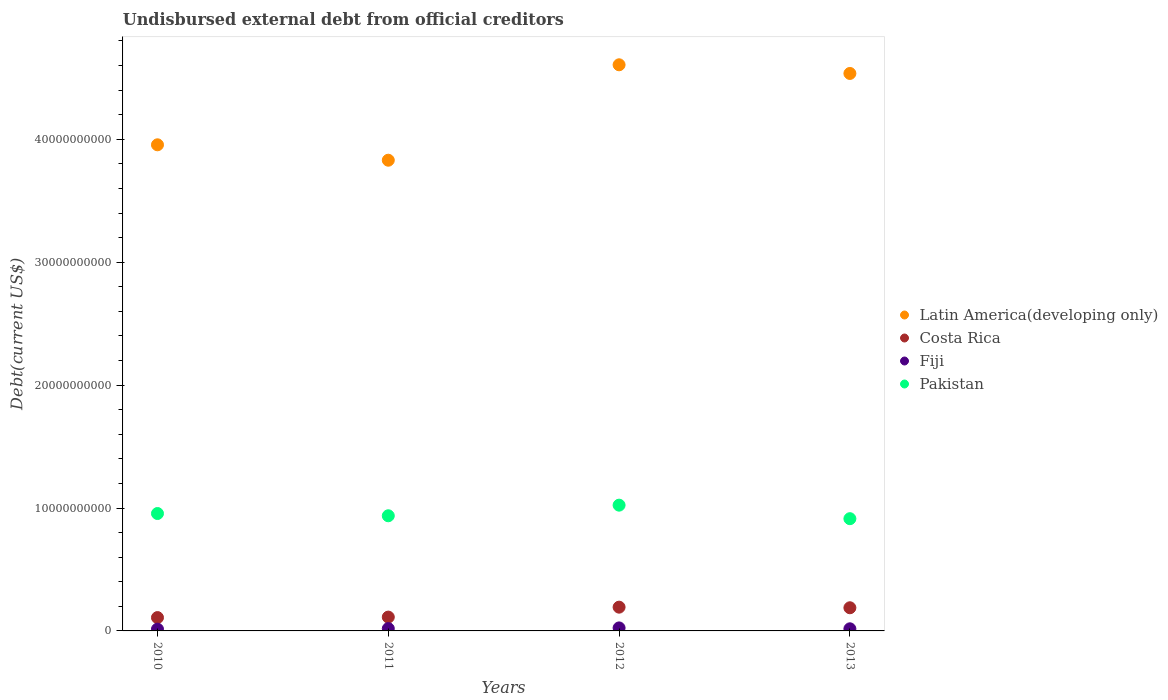How many different coloured dotlines are there?
Your response must be concise. 4. What is the total debt in Fiji in 2013?
Offer a very short reply. 1.72e+08. Across all years, what is the maximum total debt in Fiji?
Your answer should be very brief. 2.45e+08. Across all years, what is the minimum total debt in Pakistan?
Your answer should be very brief. 9.13e+09. In which year was the total debt in Pakistan maximum?
Make the answer very short. 2012. What is the total total debt in Fiji in the graph?
Give a very brief answer. 7.51e+08. What is the difference between the total debt in Latin America(developing only) in 2012 and that in 2013?
Keep it short and to the point. 7.05e+08. What is the difference between the total debt in Latin America(developing only) in 2013 and the total debt in Pakistan in 2012?
Your answer should be very brief. 3.51e+1. What is the average total debt in Costa Rica per year?
Provide a short and direct response. 1.51e+09. In the year 2011, what is the difference between the total debt in Pakistan and total debt in Fiji?
Provide a succinct answer. 9.18e+09. In how many years, is the total debt in Costa Rica greater than 32000000000 US$?
Your answer should be compact. 0. What is the ratio of the total debt in Pakistan in 2011 to that in 2013?
Make the answer very short. 1.03. Is the total debt in Pakistan in 2010 less than that in 2011?
Make the answer very short. No. Is the difference between the total debt in Pakistan in 2011 and 2013 greater than the difference between the total debt in Fiji in 2011 and 2013?
Your answer should be very brief. Yes. What is the difference between the highest and the second highest total debt in Latin America(developing only)?
Your answer should be compact. 7.05e+08. What is the difference between the highest and the lowest total debt in Latin America(developing only)?
Offer a very short reply. 7.76e+09. Is the sum of the total debt in Fiji in 2012 and 2013 greater than the maximum total debt in Costa Rica across all years?
Your answer should be compact. No. Is it the case that in every year, the sum of the total debt in Costa Rica and total debt in Latin America(developing only)  is greater than the total debt in Fiji?
Provide a short and direct response. Yes. Is the total debt in Fiji strictly greater than the total debt in Pakistan over the years?
Your answer should be compact. No. Is the total debt in Latin America(developing only) strictly less than the total debt in Fiji over the years?
Your answer should be compact. No. How many dotlines are there?
Offer a very short reply. 4. How many years are there in the graph?
Keep it short and to the point. 4. Are the values on the major ticks of Y-axis written in scientific E-notation?
Keep it short and to the point. No. How many legend labels are there?
Provide a short and direct response. 4. How are the legend labels stacked?
Keep it short and to the point. Vertical. What is the title of the graph?
Provide a succinct answer. Undisbursed external debt from official creditors. What is the label or title of the Y-axis?
Offer a terse response. Debt(current US$). What is the Debt(current US$) of Latin America(developing only) in 2010?
Your answer should be compact. 3.95e+1. What is the Debt(current US$) of Costa Rica in 2010?
Provide a short and direct response. 1.09e+09. What is the Debt(current US$) of Fiji in 2010?
Offer a very short reply. 1.44e+08. What is the Debt(current US$) in Pakistan in 2010?
Give a very brief answer. 9.55e+09. What is the Debt(current US$) of Latin America(developing only) in 2011?
Provide a succinct answer. 3.83e+1. What is the Debt(current US$) in Costa Rica in 2011?
Keep it short and to the point. 1.12e+09. What is the Debt(current US$) of Fiji in 2011?
Keep it short and to the point. 1.90e+08. What is the Debt(current US$) of Pakistan in 2011?
Provide a short and direct response. 9.37e+09. What is the Debt(current US$) of Latin America(developing only) in 2012?
Your answer should be very brief. 4.61e+1. What is the Debt(current US$) in Costa Rica in 2012?
Offer a terse response. 1.93e+09. What is the Debt(current US$) in Fiji in 2012?
Keep it short and to the point. 2.45e+08. What is the Debt(current US$) of Pakistan in 2012?
Ensure brevity in your answer.  1.02e+1. What is the Debt(current US$) in Latin America(developing only) in 2013?
Give a very brief answer. 4.54e+1. What is the Debt(current US$) of Costa Rica in 2013?
Make the answer very short. 1.88e+09. What is the Debt(current US$) in Fiji in 2013?
Your answer should be compact. 1.72e+08. What is the Debt(current US$) of Pakistan in 2013?
Your response must be concise. 9.13e+09. Across all years, what is the maximum Debt(current US$) of Latin America(developing only)?
Your response must be concise. 4.61e+1. Across all years, what is the maximum Debt(current US$) of Costa Rica?
Offer a very short reply. 1.93e+09. Across all years, what is the maximum Debt(current US$) of Fiji?
Keep it short and to the point. 2.45e+08. Across all years, what is the maximum Debt(current US$) of Pakistan?
Provide a succinct answer. 1.02e+1. Across all years, what is the minimum Debt(current US$) of Latin America(developing only)?
Make the answer very short. 3.83e+1. Across all years, what is the minimum Debt(current US$) in Costa Rica?
Your answer should be compact. 1.09e+09. Across all years, what is the minimum Debt(current US$) of Fiji?
Ensure brevity in your answer.  1.44e+08. Across all years, what is the minimum Debt(current US$) in Pakistan?
Give a very brief answer. 9.13e+09. What is the total Debt(current US$) of Latin America(developing only) in the graph?
Your response must be concise. 1.69e+11. What is the total Debt(current US$) of Costa Rica in the graph?
Keep it short and to the point. 6.03e+09. What is the total Debt(current US$) in Fiji in the graph?
Offer a very short reply. 7.51e+08. What is the total Debt(current US$) in Pakistan in the graph?
Provide a succinct answer. 3.83e+1. What is the difference between the Debt(current US$) in Latin America(developing only) in 2010 and that in 2011?
Offer a very short reply. 1.25e+09. What is the difference between the Debt(current US$) of Costa Rica in 2010 and that in 2011?
Offer a terse response. -3.95e+07. What is the difference between the Debt(current US$) of Fiji in 2010 and that in 2011?
Provide a succinct answer. -4.60e+07. What is the difference between the Debt(current US$) of Pakistan in 2010 and that in 2011?
Provide a succinct answer. 1.83e+08. What is the difference between the Debt(current US$) in Latin America(developing only) in 2010 and that in 2012?
Give a very brief answer. -6.51e+09. What is the difference between the Debt(current US$) in Costa Rica in 2010 and that in 2012?
Your response must be concise. -8.48e+08. What is the difference between the Debt(current US$) in Fiji in 2010 and that in 2012?
Make the answer very short. -1.01e+08. What is the difference between the Debt(current US$) of Pakistan in 2010 and that in 2012?
Your response must be concise. -6.80e+08. What is the difference between the Debt(current US$) in Latin America(developing only) in 2010 and that in 2013?
Give a very brief answer. -5.80e+09. What is the difference between the Debt(current US$) in Costa Rica in 2010 and that in 2013?
Keep it short and to the point. -7.99e+08. What is the difference between the Debt(current US$) in Fiji in 2010 and that in 2013?
Offer a very short reply. -2.87e+07. What is the difference between the Debt(current US$) of Pakistan in 2010 and that in 2013?
Offer a very short reply. 4.20e+08. What is the difference between the Debt(current US$) in Latin America(developing only) in 2011 and that in 2012?
Make the answer very short. -7.76e+09. What is the difference between the Debt(current US$) of Costa Rica in 2011 and that in 2012?
Your answer should be very brief. -8.08e+08. What is the difference between the Debt(current US$) of Fiji in 2011 and that in 2012?
Give a very brief answer. -5.53e+07. What is the difference between the Debt(current US$) in Pakistan in 2011 and that in 2012?
Ensure brevity in your answer.  -8.64e+08. What is the difference between the Debt(current US$) in Latin America(developing only) in 2011 and that in 2013?
Your response must be concise. -7.06e+09. What is the difference between the Debt(current US$) of Costa Rica in 2011 and that in 2013?
Keep it short and to the point. -7.59e+08. What is the difference between the Debt(current US$) of Fiji in 2011 and that in 2013?
Your response must be concise. 1.74e+07. What is the difference between the Debt(current US$) of Pakistan in 2011 and that in 2013?
Provide a succinct answer. 2.37e+08. What is the difference between the Debt(current US$) of Latin America(developing only) in 2012 and that in 2013?
Offer a very short reply. 7.05e+08. What is the difference between the Debt(current US$) in Costa Rica in 2012 and that in 2013?
Make the answer very short. 4.90e+07. What is the difference between the Debt(current US$) in Fiji in 2012 and that in 2013?
Offer a terse response. 7.26e+07. What is the difference between the Debt(current US$) in Pakistan in 2012 and that in 2013?
Give a very brief answer. 1.10e+09. What is the difference between the Debt(current US$) in Latin America(developing only) in 2010 and the Debt(current US$) in Costa Rica in 2011?
Your answer should be very brief. 3.84e+1. What is the difference between the Debt(current US$) of Latin America(developing only) in 2010 and the Debt(current US$) of Fiji in 2011?
Your response must be concise. 3.94e+1. What is the difference between the Debt(current US$) in Latin America(developing only) in 2010 and the Debt(current US$) in Pakistan in 2011?
Your response must be concise. 3.02e+1. What is the difference between the Debt(current US$) of Costa Rica in 2010 and the Debt(current US$) of Fiji in 2011?
Offer a very short reply. 8.95e+08. What is the difference between the Debt(current US$) of Costa Rica in 2010 and the Debt(current US$) of Pakistan in 2011?
Offer a very short reply. -8.28e+09. What is the difference between the Debt(current US$) of Fiji in 2010 and the Debt(current US$) of Pakistan in 2011?
Ensure brevity in your answer.  -9.22e+09. What is the difference between the Debt(current US$) of Latin America(developing only) in 2010 and the Debt(current US$) of Costa Rica in 2012?
Make the answer very short. 3.76e+1. What is the difference between the Debt(current US$) in Latin America(developing only) in 2010 and the Debt(current US$) in Fiji in 2012?
Your answer should be very brief. 3.93e+1. What is the difference between the Debt(current US$) in Latin America(developing only) in 2010 and the Debt(current US$) in Pakistan in 2012?
Your response must be concise. 2.93e+1. What is the difference between the Debt(current US$) in Costa Rica in 2010 and the Debt(current US$) in Fiji in 2012?
Ensure brevity in your answer.  8.40e+08. What is the difference between the Debt(current US$) in Costa Rica in 2010 and the Debt(current US$) in Pakistan in 2012?
Ensure brevity in your answer.  -9.15e+09. What is the difference between the Debt(current US$) of Fiji in 2010 and the Debt(current US$) of Pakistan in 2012?
Provide a short and direct response. -1.01e+1. What is the difference between the Debt(current US$) in Latin America(developing only) in 2010 and the Debt(current US$) in Costa Rica in 2013?
Your response must be concise. 3.77e+1. What is the difference between the Debt(current US$) in Latin America(developing only) in 2010 and the Debt(current US$) in Fiji in 2013?
Your answer should be compact. 3.94e+1. What is the difference between the Debt(current US$) in Latin America(developing only) in 2010 and the Debt(current US$) in Pakistan in 2013?
Give a very brief answer. 3.04e+1. What is the difference between the Debt(current US$) in Costa Rica in 2010 and the Debt(current US$) in Fiji in 2013?
Provide a succinct answer. 9.13e+08. What is the difference between the Debt(current US$) of Costa Rica in 2010 and the Debt(current US$) of Pakistan in 2013?
Provide a short and direct response. -8.05e+09. What is the difference between the Debt(current US$) in Fiji in 2010 and the Debt(current US$) in Pakistan in 2013?
Give a very brief answer. -8.99e+09. What is the difference between the Debt(current US$) in Latin America(developing only) in 2011 and the Debt(current US$) in Costa Rica in 2012?
Give a very brief answer. 3.64e+1. What is the difference between the Debt(current US$) of Latin America(developing only) in 2011 and the Debt(current US$) of Fiji in 2012?
Your answer should be compact. 3.81e+1. What is the difference between the Debt(current US$) of Latin America(developing only) in 2011 and the Debt(current US$) of Pakistan in 2012?
Offer a terse response. 2.81e+1. What is the difference between the Debt(current US$) in Costa Rica in 2011 and the Debt(current US$) in Fiji in 2012?
Ensure brevity in your answer.  8.80e+08. What is the difference between the Debt(current US$) of Costa Rica in 2011 and the Debt(current US$) of Pakistan in 2012?
Offer a terse response. -9.11e+09. What is the difference between the Debt(current US$) in Fiji in 2011 and the Debt(current US$) in Pakistan in 2012?
Ensure brevity in your answer.  -1.00e+1. What is the difference between the Debt(current US$) of Latin America(developing only) in 2011 and the Debt(current US$) of Costa Rica in 2013?
Offer a very short reply. 3.64e+1. What is the difference between the Debt(current US$) in Latin America(developing only) in 2011 and the Debt(current US$) in Fiji in 2013?
Your response must be concise. 3.81e+1. What is the difference between the Debt(current US$) in Latin America(developing only) in 2011 and the Debt(current US$) in Pakistan in 2013?
Ensure brevity in your answer.  2.92e+1. What is the difference between the Debt(current US$) of Costa Rica in 2011 and the Debt(current US$) of Fiji in 2013?
Provide a succinct answer. 9.52e+08. What is the difference between the Debt(current US$) of Costa Rica in 2011 and the Debt(current US$) of Pakistan in 2013?
Offer a very short reply. -8.01e+09. What is the difference between the Debt(current US$) in Fiji in 2011 and the Debt(current US$) in Pakistan in 2013?
Provide a short and direct response. -8.94e+09. What is the difference between the Debt(current US$) in Latin America(developing only) in 2012 and the Debt(current US$) in Costa Rica in 2013?
Provide a short and direct response. 4.42e+1. What is the difference between the Debt(current US$) of Latin America(developing only) in 2012 and the Debt(current US$) of Fiji in 2013?
Offer a very short reply. 4.59e+1. What is the difference between the Debt(current US$) in Latin America(developing only) in 2012 and the Debt(current US$) in Pakistan in 2013?
Ensure brevity in your answer.  3.69e+1. What is the difference between the Debt(current US$) in Costa Rica in 2012 and the Debt(current US$) in Fiji in 2013?
Give a very brief answer. 1.76e+09. What is the difference between the Debt(current US$) of Costa Rica in 2012 and the Debt(current US$) of Pakistan in 2013?
Provide a short and direct response. -7.20e+09. What is the difference between the Debt(current US$) in Fiji in 2012 and the Debt(current US$) in Pakistan in 2013?
Make the answer very short. -8.89e+09. What is the average Debt(current US$) in Latin America(developing only) per year?
Provide a succinct answer. 4.23e+1. What is the average Debt(current US$) of Costa Rica per year?
Provide a succinct answer. 1.51e+09. What is the average Debt(current US$) in Fiji per year?
Provide a short and direct response. 1.88e+08. What is the average Debt(current US$) in Pakistan per year?
Offer a terse response. 9.57e+09. In the year 2010, what is the difference between the Debt(current US$) in Latin America(developing only) and Debt(current US$) in Costa Rica?
Keep it short and to the point. 3.85e+1. In the year 2010, what is the difference between the Debt(current US$) of Latin America(developing only) and Debt(current US$) of Fiji?
Provide a short and direct response. 3.94e+1. In the year 2010, what is the difference between the Debt(current US$) of Latin America(developing only) and Debt(current US$) of Pakistan?
Keep it short and to the point. 3.00e+1. In the year 2010, what is the difference between the Debt(current US$) of Costa Rica and Debt(current US$) of Fiji?
Your answer should be compact. 9.42e+08. In the year 2010, what is the difference between the Debt(current US$) of Costa Rica and Debt(current US$) of Pakistan?
Your answer should be compact. -8.47e+09. In the year 2010, what is the difference between the Debt(current US$) in Fiji and Debt(current US$) in Pakistan?
Provide a succinct answer. -9.41e+09. In the year 2011, what is the difference between the Debt(current US$) in Latin America(developing only) and Debt(current US$) in Costa Rica?
Give a very brief answer. 3.72e+1. In the year 2011, what is the difference between the Debt(current US$) in Latin America(developing only) and Debt(current US$) in Fiji?
Provide a succinct answer. 3.81e+1. In the year 2011, what is the difference between the Debt(current US$) in Latin America(developing only) and Debt(current US$) in Pakistan?
Offer a terse response. 2.89e+1. In the year 2011, what is the difference between the Debt(current US$) of Costa Rica and Debt(current US$) of Fiji?
Provide a short and direct response. 9.35e+08. In the year 2011, what is the difference between the Debt(current US$) in Costa Rica and Debt(current US$) in Pakistan?
Your response must be concise. -8.24e+09. In the year 2011, what is the difference between the Debt(current US$) of Fiji and Debt(current US$) of Pakistan?
Your response must be concise. -9.18e+09. In the year 2012, what is the difference between the Debt(current US$) of Latin America(developing only) and Debt(current US$) of Costa Rica?
Offer a terse response. 4.41e+1. In the year 2012, what is the difference between the Debt(current US$) of Latin America(developing only) and Debt(current US$) of Fiji?
Provide a short and direct response. 4.58e+1. In the year 2012, what is the difference between the Debt(current US$) of Latin America(developing only) and Debt(current US$) of Pakistan?
Your response must be concise. 3.58e+1. In the year 2012, what is the difference between the Debt(current US$) of Costa Rica and Debt(current US$) of Fiji?
Ensure brevity in your answer.  1.69e+09. In the year 2012, what is the difference between the Debt(current US$) of Costa Rica and Debt(current US$) of Pakistan?
Keep it short and to the point. -8.30e+09. In the year 2012, what is the difference between the Debt(current US$) in Fiji and Debt(current US$) in Pakistan?
Give a very brief answer. -9.99e+09. In the year 2013, what is the difference between the Debt(current US$) in Latin America(developing only) and Debt(current US$) in Costa Rica?
Offer a very short reply. 4.35e+1. In the year 2013, what is the difference between the Debt(current US$) in Latin America(developing only) and Debt(current US$) in Fiji?
Provide a succinct answer. 4.52e+1. In the year 2013, what is the difference between the Debt(current US$) of Latin America(developing only) and Debt(current US$) of Pakistan?
Your answer should be very brief. 3.62e+1. In the year 2013, what is the difference between the Debt(current US$) in Costa Rica and Debt(current US$) in Fiji?
Give a very brief answer. 1.71e+09. In the year 2013, what is the difference between the Debt(current US$) in Costa Rica and Debt(current US$) in Pakistan?
Offer a very short reply. -7.25e+09. In the year 2013, what is the difference between the Debt(current US$) of Fiji and Debt(current US$) of Pakistan?
Offer a very short reply. -8.96e+09. What is the ratio of the Debt(current US$) in Latin America(developing only) in 2010 to that in 2011?
Ensure brevity in your answer.  1.03. What is the ratio of the Debt(current US$) of Costa Rica in 2010 to that in 2011?
Provide a short and direct response. 0.96. What is the ratio of the Debt(current US$) in Fiji in 2010 to that in 2011?
Your answer should be compact. 0.76. What is the ratio of the Debt(current US$) in Pakistan in 2010 to that in 2011?
Your response must be concise. 1.02. What is the ratio of the Debt(current US$) in Latin America(developing only) in 2010 to that in 2012?
Ensure brevity in your answer.  0.86. What is the ratio of the Debt(current US$) of Costa Rica in 2010 to that in 2012?
Offer a terse response. 0.56. What is the ratio of the Debt(current US$) of Fiji in 2010 to that in 2012?
Provide a short and direct response. 0.59. What is the ratio of the Debt(current US$) of Pakistan in 2010 to that in 2012?
Your answer should be compact. 0.93. What is the ratio of the Debt(current US$) of Latin America(developing only) in 2010 to that in 2013?
Make the answer very short. 0.87. What is the ratio of the Debt(current US$) of Costa Rica in 2010 to that in 2013?
Provide a short and direct response. 0.58. What is the ratio of the Debt(current US$) of Fiji in 2010 to that in 2013?
Give a very brief answer. 0.83. What is the ratio of the Debt(current US$) in Pakistan in 2010 to that in 2013?
Ensure brevity in your answer.  1.05. What is the ratio of the Debt(current US$) of Latin America(developing only) in 2011 to that in 2012?
Your answer should be very brief. 0.83. What is the ratio of the Debt(current US$) in Costa Rica in 2011 to that in 2012?
Keep it short and to the point. 0.58. What is the ratio of the Debt(current US$) in Fiji in 2011 to that in 2012?
Give a very brief answer. 0.77. What is the ratio of the Debt(current US$) in Pakistan in 2011 to that in 2012?
Your response must be concise. 0.92. What is the ratio of the Debt(current US$) of Latin America(developing only) in 2011 to that in 2013?
Ensure brevity in your answer.  0.84. What is the ratio of the Debt(current US$) in Costa Rica in 2011 to that in 2013?
Provide a short and direct response. 0.6. What is the ratio of the Debt(current US$) in Fiji in 2011 to that in 2013?
Make the answer very short. 1.1. What is the ratio of the Debt(current US$) of Pakistan in 2011 to that in 2013?
Offer a terse response. 1.03. What is the ratio of the Debt(current US$) in Latin America(developing only) in 2012 to that in 2013?
Keep it short and to the point. 1.02. What is the ratio of the Debt(current US$) in Costa Rica in 2012 to that in 2013?
Ensure brevity in your answer.  1.03. What is the ratio of the Debt(current US$) in Fiji in 2012 to that in 2013?
Offer a terse response. 1.42. What is the ratio of the Debt(current US$) in Pakistan in 2012 to that in 2013?
Provide a short and direct response. 1.12. What is the difference between the highest and the second highest Debt(current US$) of Latin America(developing only)?
Keep it short and to the point. 7.05e+08. What is the difference between the highest and the second highest Debt(current US$) in Costa Rica?
Your answer should be compact. 4.90e+07. What is the difference between the highest and the second highest Debt(current US$) of Fiji?
Ensure brevity in your answer.  5.53e+07. What is the difference between the highest and the second highest Debt(current US$) in Pakistan?
Provide a succinct answer. 6.80e+08. What is the difference between the highest and the lowest Debt(current US$) of Latin America(developing only)?
Your answer should be very brief. 7.76e+09. What is the difference between the highest and the lowest Debt(current US$) in Costa Rica?
Provide a succinct answer. 8.48e+08. What is the difference between the highest and the lowest Debt(current US$) in Fiji?
Keep it short and to the point. 1.01e+08. What is the difference between the highest and the lowest Debt(current US$) of Pakistan?
Your answer should be compact. 1.10e+09. 